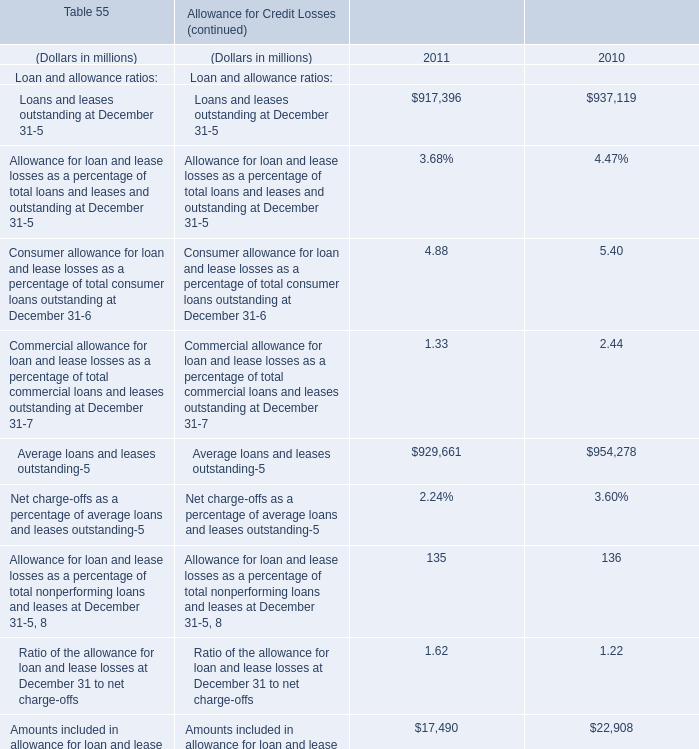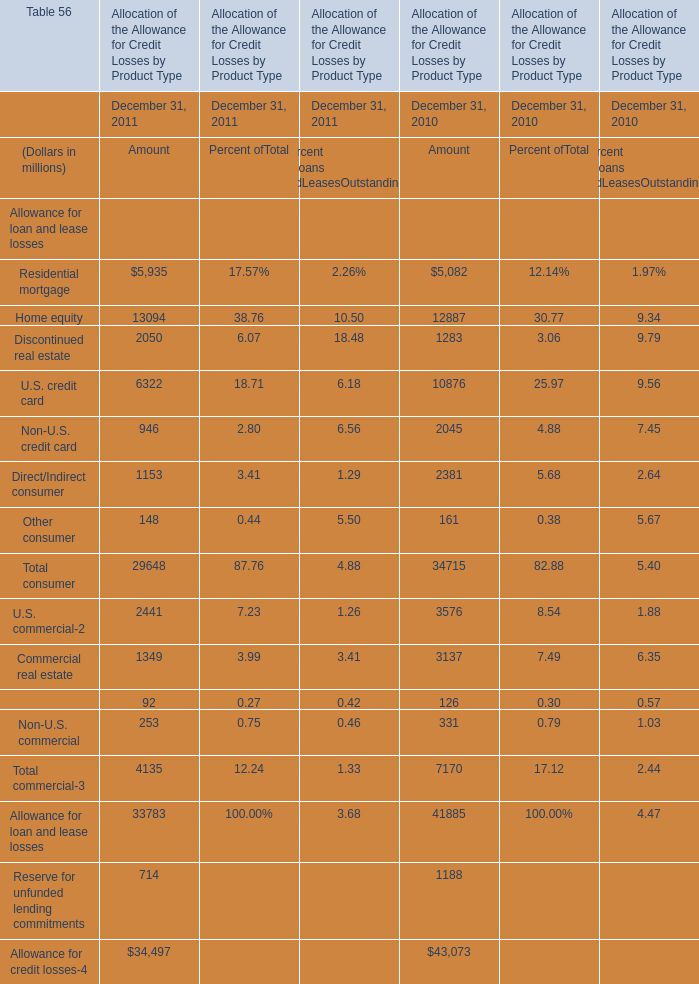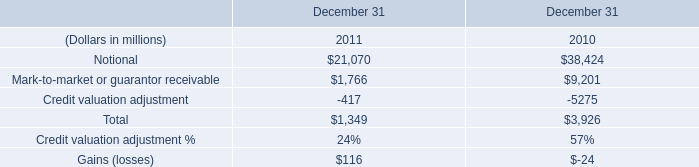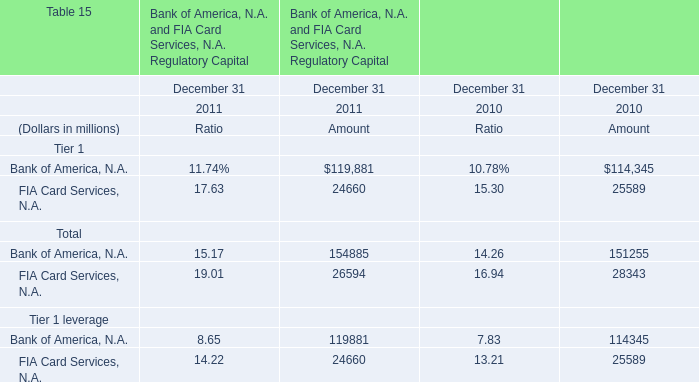What's the sum of Amount without those Amount greater than 200, in 2011 for Allocation of the Allowance for Credit Losses by Product Type? (in million) 
Computations: (148 + 92)
Answer: 240.0. 